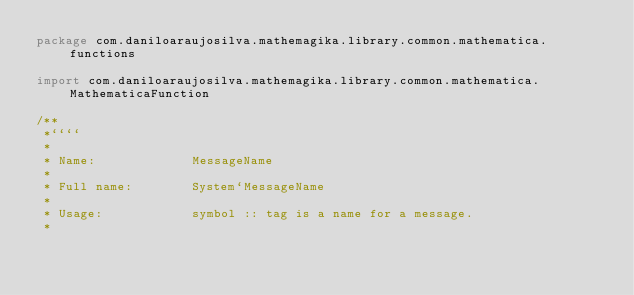Convert code to text. <code><loc_0><loc_0><loc_500><loc_500><_Kotlin_>package com.daniloaraujosilva.mathemagika.library.common.mathematica.functions

import com.daniloaraujosilva.mathemagika.library.common.mathematica.MathematicaFunction

/**
 *````
 *
 * Name:             MessageName
 *
 * Full name:        System`MessageName
 *
 * Usage:            symbol :: tag is a name for a message.
 *</code> 